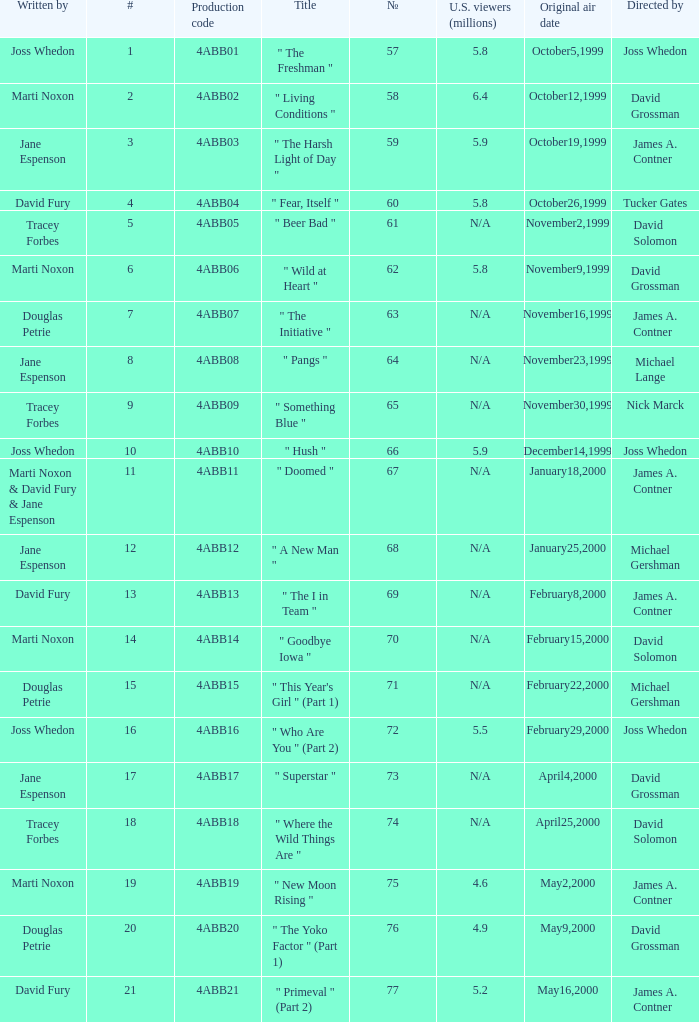What is the production code for the episode with 5.5 million u.s. viewers? 4ABB16. 